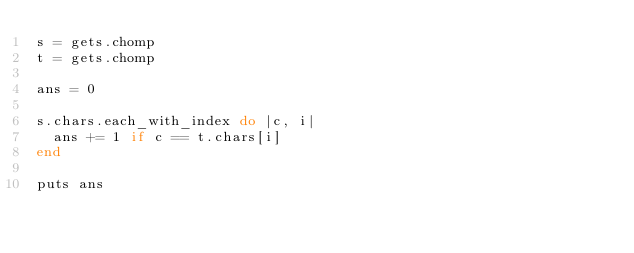<code> <loc_0><loc_0><loc_500><loc_500><_Ruby_>s = gets.chomp
t = gets.chomp

ans = 0

s.chars.each_with_index do |c, i|
  ans += 1 if c == t.chars[i]
end

puts ans</code> 